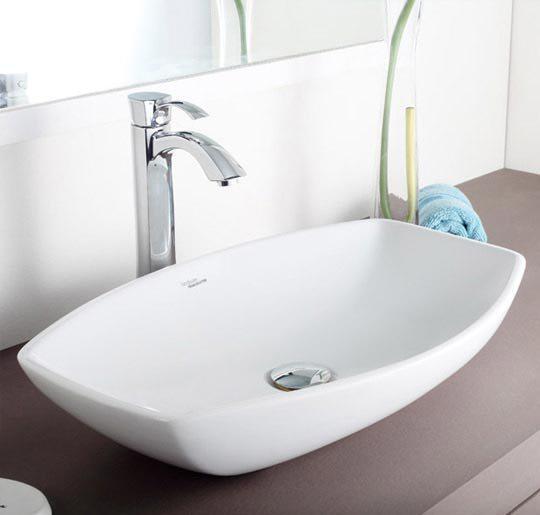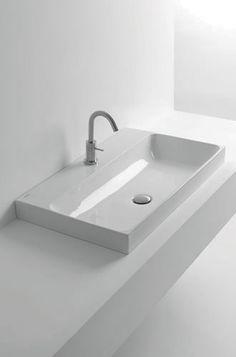The first image is the image on the left, the second image is the image on the right. Given the left and right images, does the statement "In one image, the chrome water spout is shaped like a rounded arc over the rectangular sink area." hold true? Answer yes or no. Yes. 